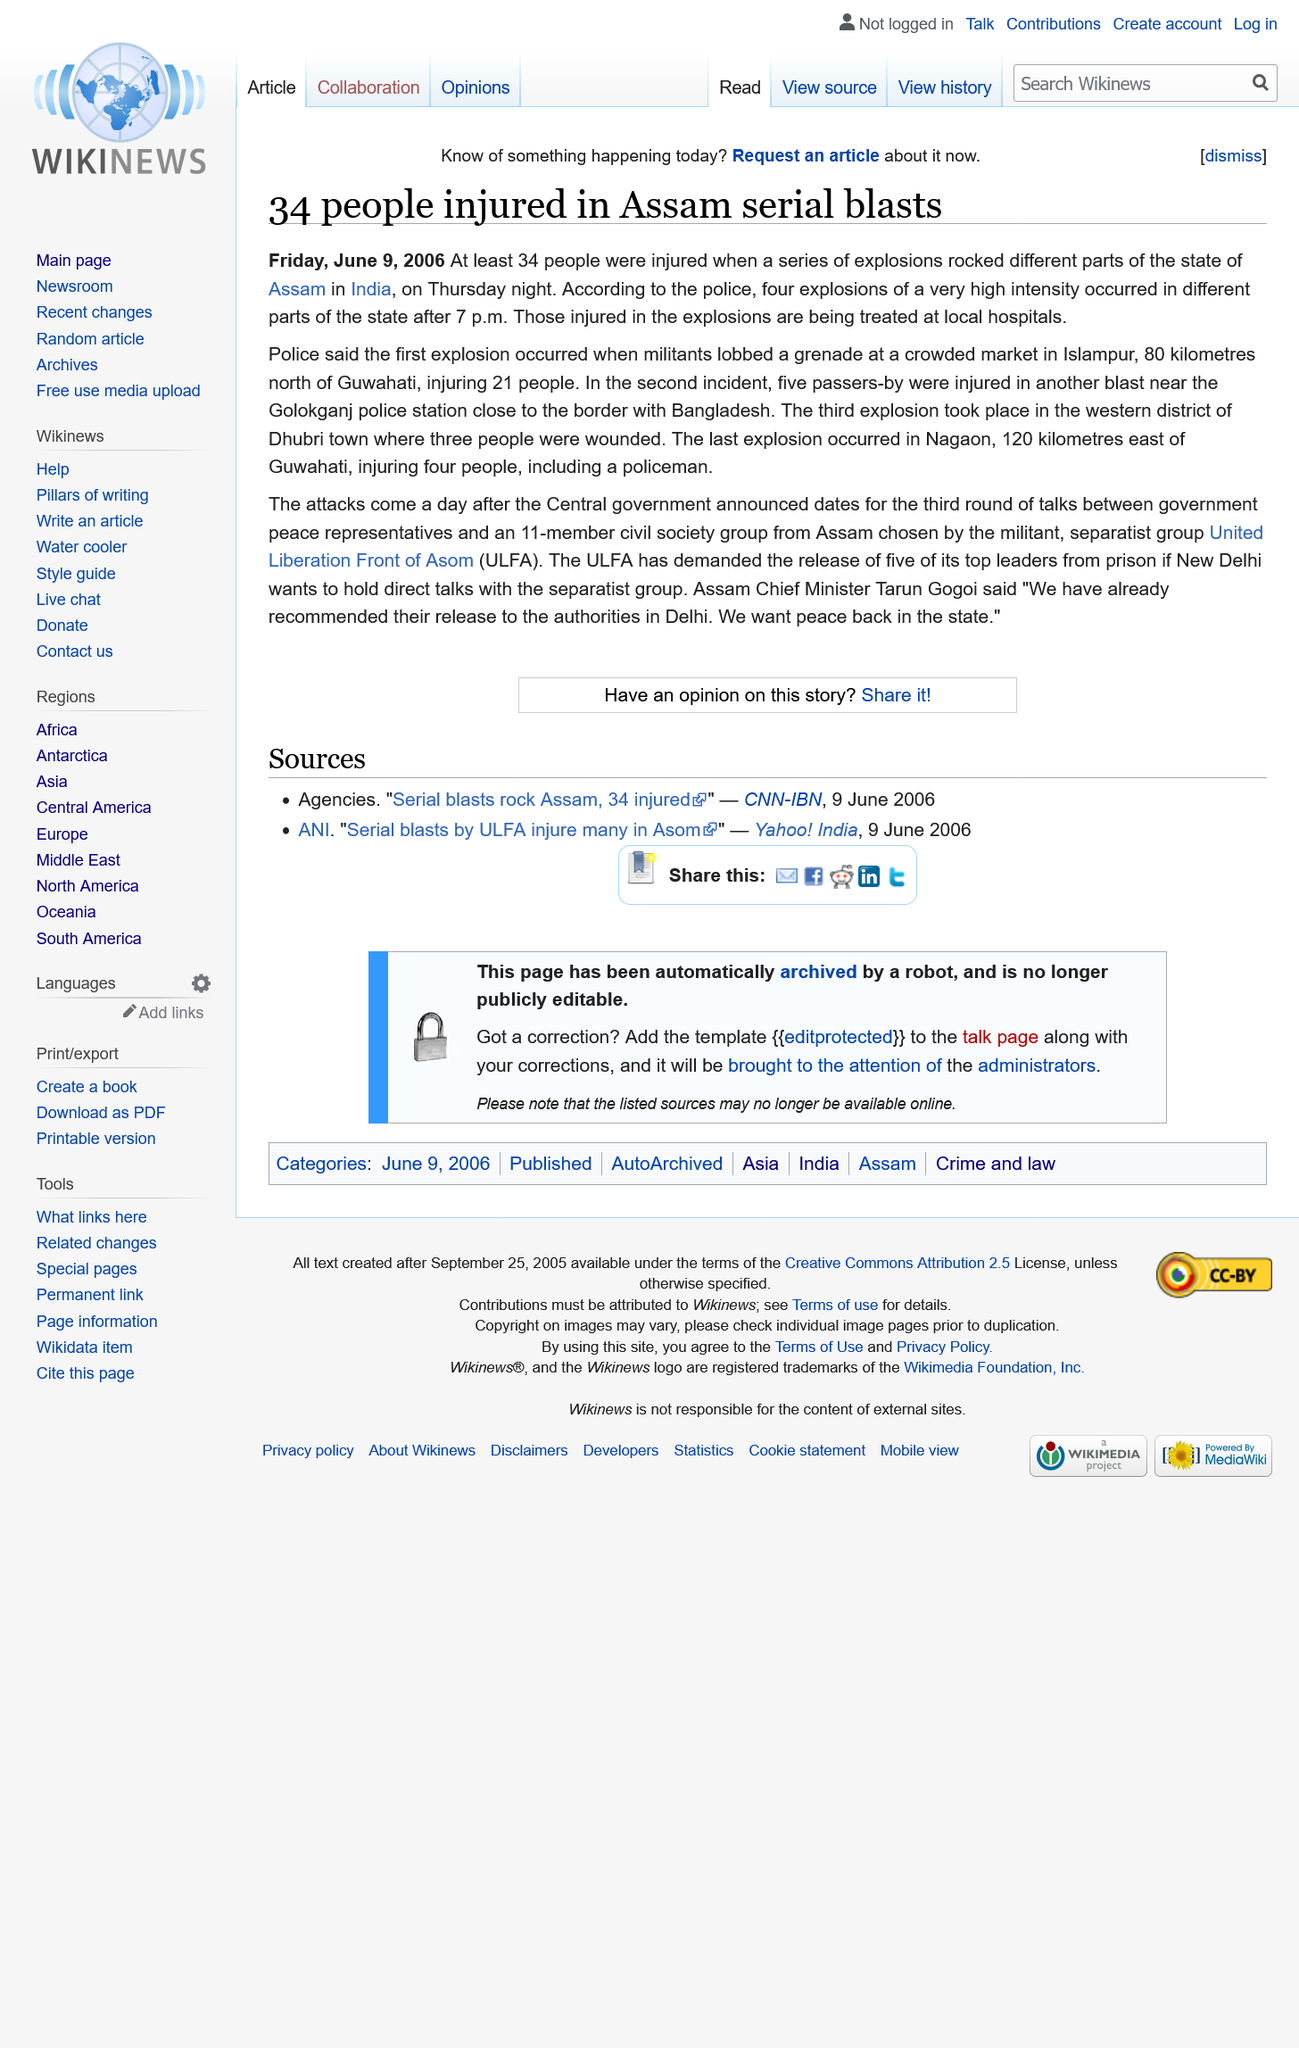Give some essential details in this illustration. In total, there were 4 explosions. A total of 34 people were injured. 21 individuals were injured in the initial incident. 